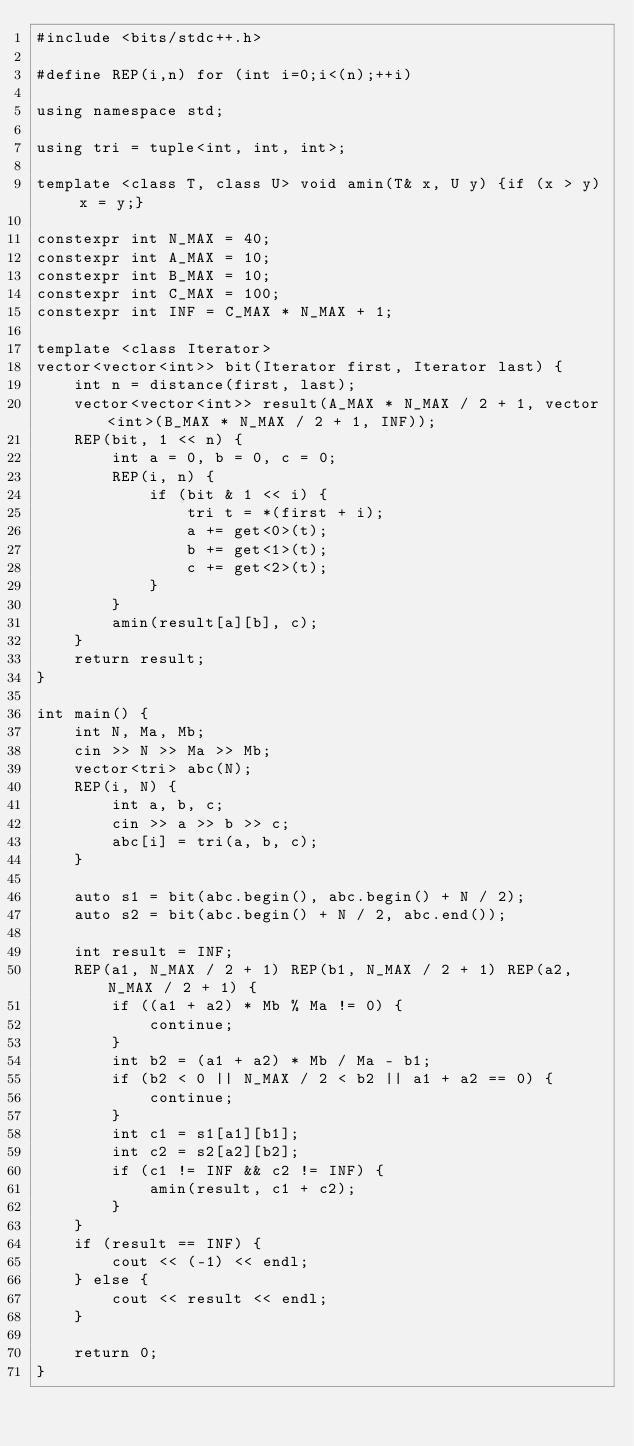<code> <loc_0><loc_0><loc_500><loc_500><_C++_>#include <bits/stdc++.h>

#define REP(i,n) for (int i=0;i<(n);++i)

using namespace std;

using tri = tuple<int, int, int>;

template <class T, class U> void amin(T& x, U y) {if (x > y) x = y;}

constexpr int N_MAX = 40;
constexpr int A_MAX = 10;
constexpr int B_MAX = 10;
constexpr int C_MAX = 100;
constexpr int INF = C_MAX * N_MAX + 1;

template <class Iterator>
vector<vector<int>> bit(Iterator first, Iterator last) {
    int n = distance(first, last);
    vector<vector<int>> result(A_MAX * N_MAX / 2 + 1, vector<int>(B_MAX * N_MAX / 2 + 1, INF));
    REP(bit, 1 << n) {
        int a = 0, b = 0, c = 0;
        REP(i, n) {
            if (bit & 1 << i) {
                tri t = *(first + i);
                a += get<0>(t);
                b += get<1>(t);
                c += get<2>(t);
            }
        }
        amin(result[a][b], c);
    }
    return result;
}

int main() {
    int N, Ma, Mb;
    cin >> N >> Ma >> Mb;
    vector<tri> abc(N);
    REP(i, N) {
        int a, b, c;
        cin >> a >> b >> c;
        abc[i] = tri(a, b, c);
    }

    auto s1 = bit(abc.begin(), abc.begin() + N / 2);
    auto s2 = bit(abc.begin() + N / 2, abc.end());

    int result = INF;
    REP(a1, N_MAX / 2 + 1) REP(b1, N_MAX / 2 + 1) REP(a2, N_MAX / 2 + 1) {
        if ((a1 + a2) * Mb % Ma != 0) {
            continue;
        }
        int b2 = (a1 + a2) * Mb / Ma - b1;
        if (b2 < 0 || N_MAX / 2 < b2 || a1 + a2 == 0) {
            continue;
        }
        int c1 = s1[a1][b1];
        int c2 = s2[a2][b2];
        if (c1 != INF && c2 != INF) {
            amin(result, c1 + c2);
        }
    }
    if (result == INF) {
        cout << (-1) << endl;
    } else {
        cout << result << endl;
    }

    return 0;
}</code> 